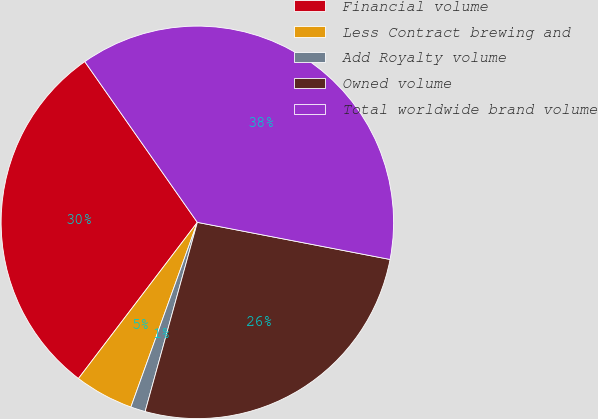<chart> <loc_0><loc_0><loc_500><loc_500><pie_chart><fcel>Financial volume<fcel>Less Contract brewing and<fcel>Add Royalty volume<fcel>Owned volume<fcel>Total worldwide brand volume<nl><fcel>29.92%<fcel>4.86%<fcel>1.21%<fcel>26.26%<fcel>37.75%<nl></chart> 